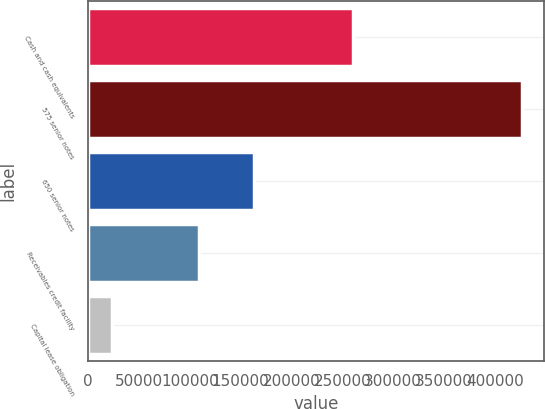Convert chart to OTSL. <chart><loc_0><loc_0><loc_500><loc_500><bar_chart><fcel>Cash and cash equivalents<fcel>575 senior notes<fcel>650 senior notes<fcel>Receivables credit facility<fcel>Capital lease obligation<nl><fcel>260727<fcel>427000<fcel>163500<fcel>109000<fcel>23129<nl></chart> 